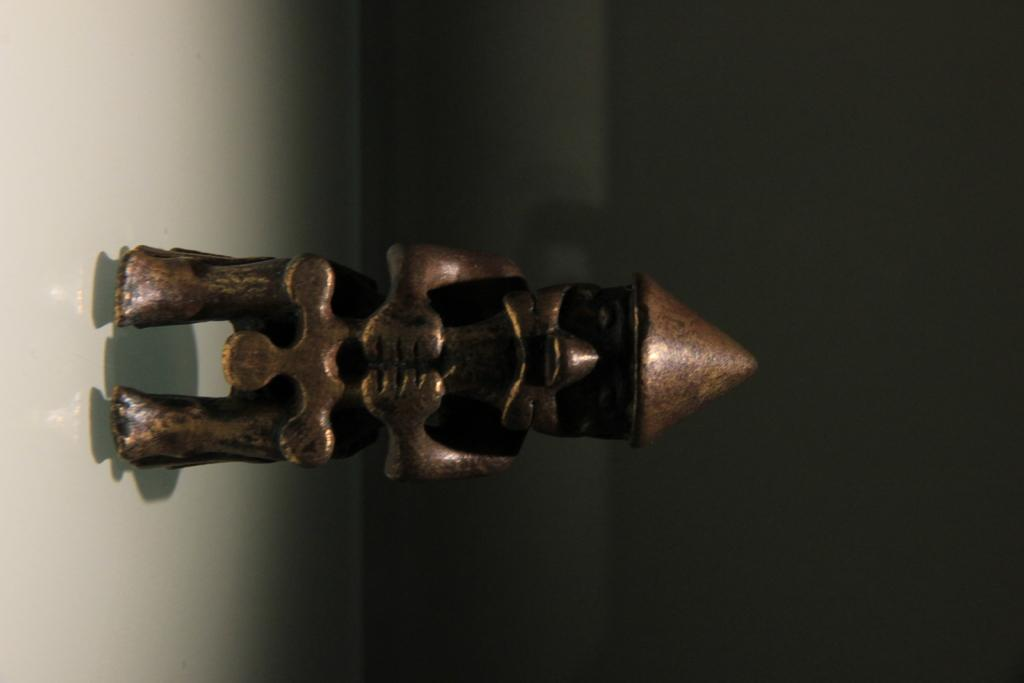What type of object is the main subject of the image? There is a metal statue in the image. What type of flooring is visible beneath the metal statue in the image? The provided facts do not mention any flooring beneath the metal statue, so it cannot be determined from the image. 